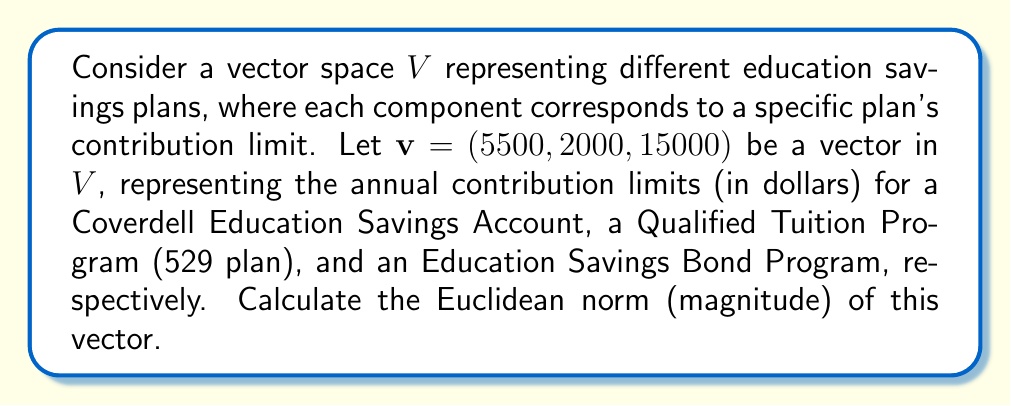Provide a solution to this math problem. To solve this problem, we'll follow these steps:

1) The Euclidean norm (also known as the L2 norm) of a vector $v = (v_1, v_2, ..., v_n)$ is defined as:

   $$\|v\| = \sqrt{\sum_{i=1}^n |v_i|^2}$$

2) In our case, we have $v = (5500, 2000, 15000)$. Let's substitute these values:

   $$\|v\| = \sqrt{|5500|^2 + |2000|^2 + |15000|^2}$$

3) Simplify the squares:

   $$\|v\| = \sqrt{30250000 + 4000000 + 225000000}$$

4) Add the terms under the square root:

   $$\|v\| = \sqrt{259250000}$$

5) Calculate the square root:

   $$\|v\| = 16101.24...$$

6) Rounding to two decimal places:

   $$\|v\| \approx 16101.24$$

This result represents the Euclidean distance of the vector from the origin in the 3-dimensional space of education savings plan contribution limits.
Answer: $16101.24$ (rounded to two decimal places) 